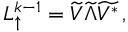Convert formula to latex. <formula><loc_0><loc_0><loc_500><loc_500>\begin{array} { r } { L _ { \uparrow } ^ { k - 1 } = \widetilde { V } \widetilde { \Lambda } \widetilde { V ^ { * } } \, , } \end{array}</formula> 